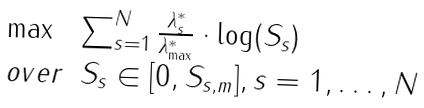Convert formula to latex. <formula><loc_0><loc_0><loc_500><loc_500>\begin{array} { l l } \max & \sum _ { s = 1 } ^ { N } \frac { \lambda ^ { * } _ { s } } { \lambda ^ { * } _ { \max } } \cdot \log ( S _ { s } ) \\ o v e r & S _ { s } \in [ 0 , S _ { s , m } ] , s = 1 , \dots , N \end{array}</formula> 